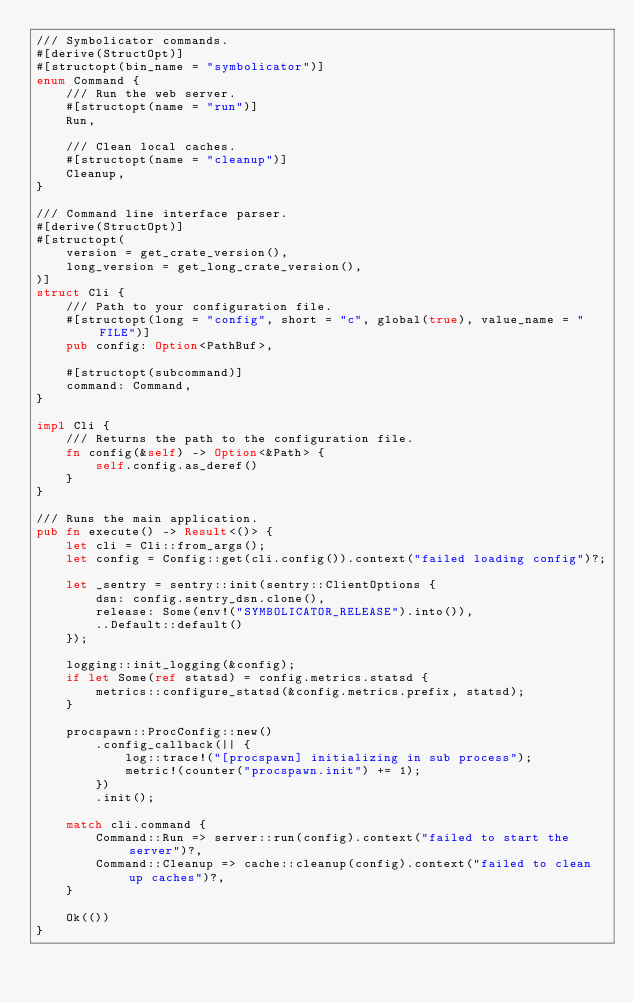Convert code to text. <code><loc_0><loc_0><loc_500><loc_500><_Rust_>/// Symbolicator commands.
#[derive(StructOpt)]
#[structopt(bin_name = "symbolicator")]
enum Command {
    /// Run the web server.
    #[structopt(name = "run")]
    Run,

    /// Clean local caches.
    #[structopt(name = "cleanup")]
    Cleanup,
}

/// Command line interface parser.
#[derive(StructOpt)]
#[structopt(
    version = get_crate_version(),
    long_version = get_long_crate_version(),
)]
struct Cli {
    /// Path to your configuration file.
    #[structopt(long = "config", short = "c", global(true), value_name = "FILE")]
    pub config: Option<PathBuf>,

    #[structopt(subcommand)]
    command: Command,
}

impl Cli {
    /// Returns the path to the configuration file.
    fn config(&self) -> Option<&Path> {
        self.config.as_deref()
    }
}

/// Runs the main application.
pub fn execute() -> Result<()> {
    let cli = Cli::from_args();
    let config = Config::get(cli.config()).context("failed loading config")?;

    let _sentry = sentry::init(sentry::ClientOptions {
        dsn: config.sentry_dsn.clone(),
        release: Some(env!("SYMBOLICATOR_RELEASE").into()),
        ..Default::default()
    });

    logging::init_logging(&config);
    if let Some(ref statsd) = config.metrics.statsd {
        metrics::configure_statsd(&config.metrics.prefix, statsd);
    }

    procspawn::ProcConfig::new()
        .config_callback(|| {
            log::trace!("[procspawn] initializing in sub process");
            metric!(counter("procspawn.init") += 1);
        })
        .init();

    match cli.command {
        Command::Run => server::run(config).context("failed to start the server")?,
        Command::Cleanup => cache::cleanup(config).context("failed to clean up caches")?,
    }

    Ok(())
}
</code> 